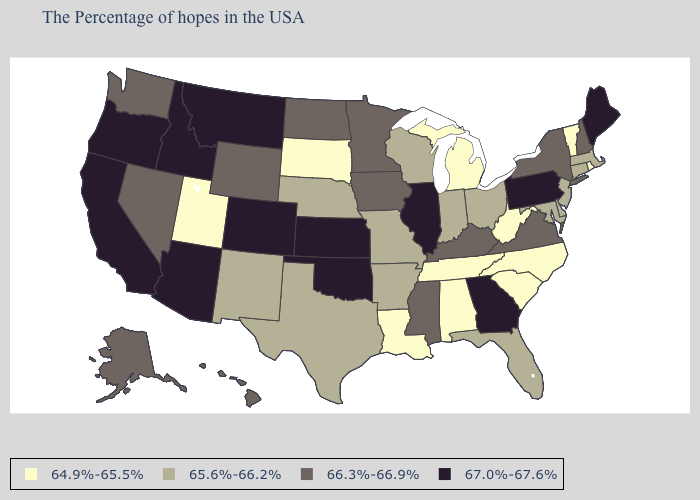Does Pennsylvania have the lowest value in the Northeast?
Short answer required. No. Among the states that border Rhode Island , which have the lowest value?
Give a very brief answer. Massachusetts, Connecticut. What is the value of Massachusetts?
Write a very short answer. 65.6%-66.2%. Does the map have missing data?
Quick response, please. No. Which states hav the highest value in the MidWest?
Write a very short answer. Illinois, Kansas. Name the states that have a value in the range 66.3%-66.9%?
Give a very brief answer. New Hampshire, New York, Virginia, Kentucky, Mississippi, Minnesota, Iowa, North Dakota, Wyoming, Nevada, Washington, Alaska, Hawaii. What is the value of Utah?
Write a very short answer. 64.9%-65.5%. Does Kansas have the highest value in the MidWest?
Quick response, please. Yes. Which states have the lowest value in the USA?
Keep it brief. Rhode Island, Vermont, North Carolina, South Carolina, West Virginia, Michigan, Alabama, Tennessee, Louisiana, South Dakota, Utah. Is the legend a continuous bar?
Give a very brief answer. No. What is the value of Louisiana?
Write a very short answer. 64.9%-65.5%. What is the value of Massachusetts?
Answer briefly. 65.6%-66.2%. What is the value of Florida?
Short answer required. 65.6%-66.2%. Does Nevada have the highest value in the West?
Concise answer only. No. What is the value of Massachusetts?
Be succinct. 65.6%-66.2%. 